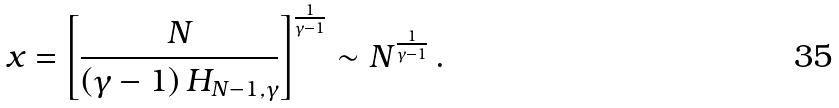<formula> <loc_0><loc_0><loc_500><loc_500>x = \left [ \frac { N } { \left ( \gamma - 1 \right ) H _ { N - 1 , \gamma } } \right ] ^ { \frac { 1 } { \gamma - 1 } } \sim N ^ { \frac { 1 } { \gamma - 1 } } \, .</formula> 